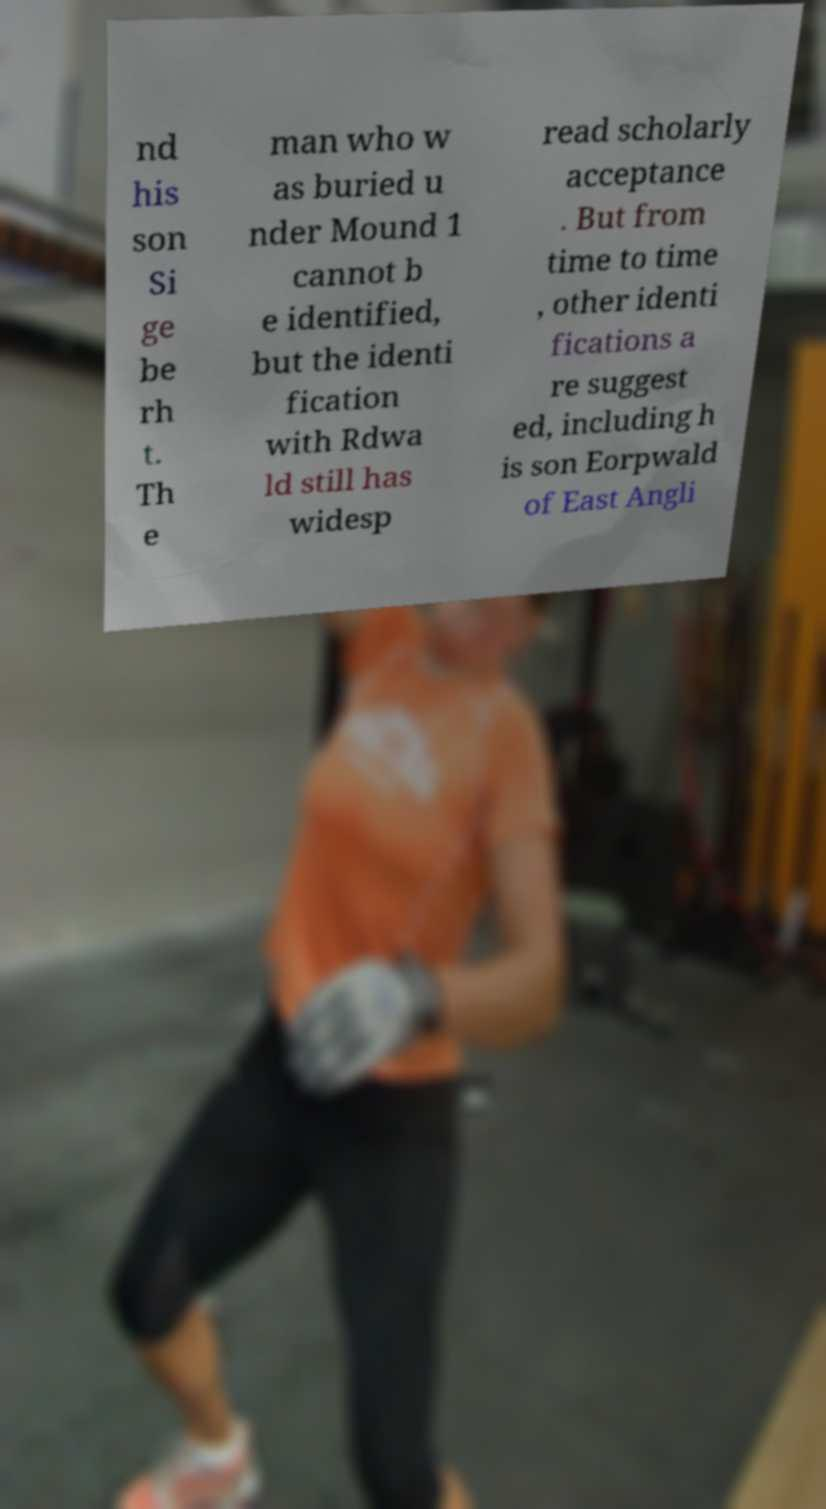Could you extract and type out the text from this image? nd his son Si ge be rh t. Th e man who w as buried u nder Mound 1 cannot b e identified, but the identi fication with Rdwa ld still has widesp read scholarly acceptance . But from time to time , other identi fications a re suggest ed, including h is son Eorpwald of East Angli 